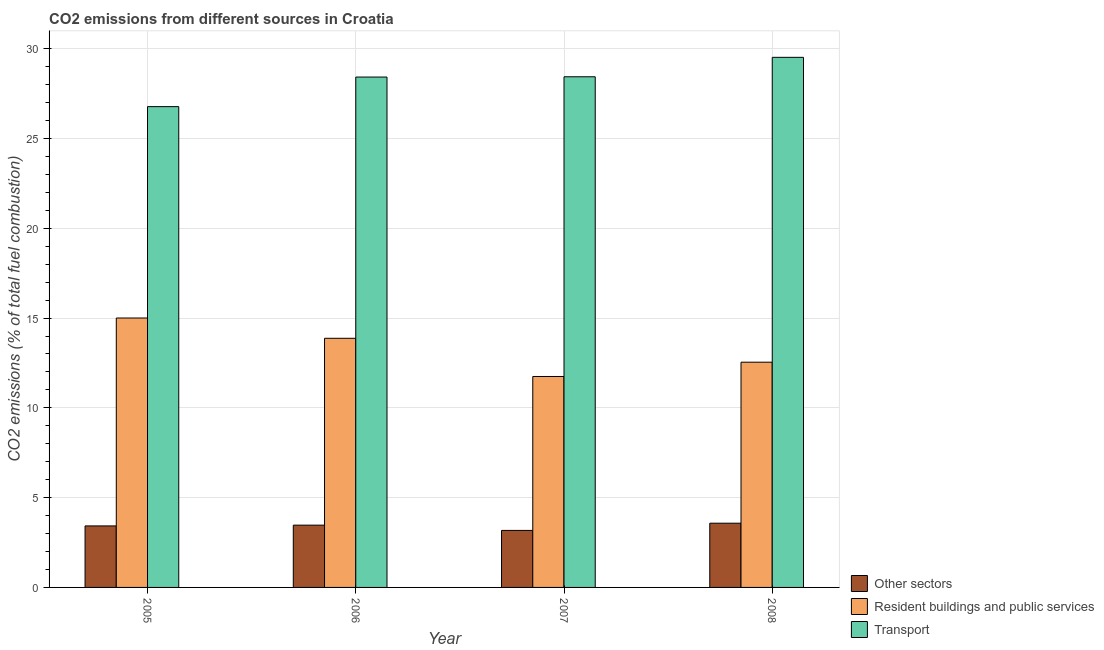How many different coloured bars are there?
Your response must be concise. 3. Are the number of bars per tick equal to the number of legend labels?
Provide a succinct answer. Yes. How many bars are there on the 2nd tick from the left?
Offer a very short reply. 3. How many bars are there on the 1st tick from the right?
Give a very brief answer. 3. In how many cases, is the number of bars for a given year not equal to the number of legend labels?
Offer a terse response. 0. What is the percentage of co2 emissions from transport in 2007?
Offer a terse response. 28.44. Across all years, what is the maximum percentage of co2 emissions from resident buildings and public services?
Keep it short and to the point. 15. Across all years, what is the minimum percentage of co2 emissions from other sectors?
Keep it short and to the point. 3.17. What is the total percentage of co2 emissions from transport in the graph?
Keep it short and to the point. 113.15. What is the difference between the percentage of co2 emissions from resident buildings and public services in 2005 and that in 2006?
Your answer should be very brief. 1.13. What is the difference between the percentage of co2 emissions from other sectors in 2007 and the percentage of co2 emissions from transport in 2005?
Ensure brevity in your answer.  -0.25. What is the average percentage of co2 emissions from resident buildings and public services per year?
Offer a very short reply. 13.29. In how many years, is the percentage of co2 emissions from transport greater than 11 %?
Make the answer very short. 4. What is the ratio of the percentage of co2 emissions from transport in 2007 to that in 2008?
Ensure brevity in your answer.  0.96. Is the percentage of co2 emissions from other sectors in 2006 less than that in 2007?
Offer a very short reply. No. Is the difference between the percentage of co2 emissions from transport in 2005 and 2006 greater than the difference between the percentage of co2 emissions from resident buildings and public services in 2005 and 2006?
Make the answer very short. No. What is the difference between the highest and the second highest percentage of co2 emissions from transport?
Make the answer very short. 1.08. What is the difference between the highest and the lowest percentage of co2 emissions from transport?
Ensure brevity in your answer.  2.75. In how many years, is the percentage of co2 emissions from transport greater than the average percentage of co2 emissions from transport taken over all years?
Give a very brief answer. 3. What does the 3rd bar from the left in 2007 represents?
Give a very brief answer. Transport. What does the 1st bar from the right in 2006 represents?
Make the answer very short. Transport. Are all the bars in the graph horizontal?
Provide a short and direct response. No. Where does the legend appear in the graph?
Keep it short and to the point. Bottom right. What is the title of the graph?
Offer a terse response. CO2 emissions from different sources in Croatia. What is the label or title of the Y-axis?
Your answer should be very brief. CO2 emissions (% of total fuel combustion). What is the CO2 emissions (% of total fuel combustion) of Other sectors in 2005?
Ensure brevity in your answer.  3.42. What is the CO2 emissions (% of total fuel combustion) in Resident buildings and public services in 2005?
Provide a succinct answer. 15. What is the CO2 emissions (% of total fuel combustion) of Transport in 2005?
Provide a short and direct response. 26.77. What is the CO2 emissions (% of total fuel combustion) of Other sectors in 2006?
Keep it short and to the point. 3.47. What is the CO2 emissions (% of total fuel combustion) in Resident buildings and public services in 2006?
Offer a very short reply. 13.87. What is the CO2 emissions (% of total fuel combustion) in Transport in 2006?
Keep it short and to the point. 28.42. What is the CO2 emissions (% of total fuel combustion) in Other sectors in 2007?
Offer a very short reply. 3.17. What is the CO2 emissions (% of total fuel combustion) of Resident buildings and public services in 2007?
Your answer should be very brief. 11.75. What is the CO2 emissions (% of total fuel combustion) in Transport in 2007?
Make the answer very short. 28.44. What is the CO2 emissions (% of total fuel combustion) of Other sectors in 2008?
Give a very brief answer. 3.58. What is the CO2 emissions (% of total fuel combustion) in Resident buildings and public services in 2008?
Give a very brief answer. 12.54. What is the CO2 emissions (% of total fuel combustion) of Transport in 2008?
Your response must be concise. 29.52. Across all years, what is the maximum CO2 emissions (% of total fuel combustion) in Other sectors?
Offer a terse response. 3.58. Across all years, what is the maximum CO2 emissions (% of total fuel combustion) in Resident buildings and public services?
Provide a succinct answer. 15. Across all years, what is the maximum CO2 emissions (% of total fuel combustion) in Transport?
Offer a terse response. 29.52. Across all years, what is the minimum CO2 emissions (% of total fuel combustion) of Other sectors?
Provide a short and direct response. 3.17. Across all years, what is the minimum CO2 emissions (% of total fuel combustion) in Resident buildings and public services?
Your answer should be very brief. 11.75. Across all years, what is the minimum CO2 emissions (% of total fuel combustion) in Transport?
Offer a very short reply. 26.77. What is the total CO2 emissions (% of total fuel combustion) in Other sectors in the graph?
Offer a terse response. 13.64. What is the total CO2 emissions (% of total fuel combustion) in Resident buildings and public services in the graph?
Your answer should be compact. 53.16. What is the total CO2 emissions (% of total fuel combustion) of Transport in the graph?
Your answer should be very brief. 113.15. What is the difference between the CO2 emissions (% of total fuel combustion) of Other sectors in 2005 and that in 2006?
Offer a terse response. -0.04. What is the difference between the CO2 emissions (% of total fuel combustion) of Resident buildings and public services in 2005 and that in 2006?
Make the answer very short. 1.13. What is the difference between the CO2 emissions (% of total fuel combustion) of Transport in 2005 and that in 2006?
Your response must be concise. -1.65. What is the difference between the CO2 emissions (% of total fuel combustion) in Other sectors in 2005 and that in 2007?
Offer a very short reply. 0.25. What is the difference between the CO2 emissions (% of total fuel combustion) of Resident buildings and public services in 2005 and that in 2007?
Ensure brevity in your answer.  3.26. What is the difference between the CO2 emissions (% of total fuel combustion) of Transport in 2005 and that in 2007?
Your answer should be very brief. -1.66. What is the difference between the CO2 emissions (% of total fuel combustion) of Other sectors in 2005 and that in 2008?
Provide a succinct answer. -0.15. What is the difference between the CO2 emissions (% of total fuel combustion) of Resident buildings and public services in 2005 and that in 2008?
Offer a terse response. 2.46. What is the difference between the CO2 emissions (% of total fuel combustion) in Transport in 2005 and that in 2008?
Ensure brevity in your answer.  -2.75. What is the difference between the CO2 emissions (% of total fuel combustion) of Other sectors in 2006 and that in 2007?
Give a very brief answer. 0.29. What is the difference between the CO2 emissions (% of total fuel combustion) in Resident buildings and public services in 2006 and that in 2007?
Your response must be concise. 2.13. What is the difference between the CO2 emissions (% of total fuel combustion) of Transport in 2006 and that in 2007?
Provide a short and direct response. -0.02. What is the difference between the CO2 emissions (% of total fuel combustion) in Other sectors in 2006 and that in 2008?
Provide a short and direct response. -0.11. What is the difference between the CO2 emissions (% of total fuel combustion) in Resident buildings and public services in 2006 and that in 2008?
Offer a very short reply. 1.33. What is the difference between the CO2 emissions (% of total fuel combustion) of Transport in 2006 and that in 2008?
Your answer should be very brief. -1.1. What is the difference between the CO2 emissions (% of total fuel combustion) of Other sectors in 2007 and that in 2008?
Offer a terse response. -0.4. What is the difference between the CO2 emissions (% of total fuel combustion) in Resident buildings and public services in 2007 and that in 2008?
Provide a short and direct response. -0.8. What is the difference between the CO2 emissions (% of total fuel combustion) in Transport in 2007 and that in 2008?
Your answer should be very brief. -1.08. What is the difference between the CO2 emissions (% of total fuel combustion) of Other sectors in 2005 and the CO2 emissions (% of total fuel combustion) of Resident buildings and public services in 2006?
Offer a very short reply. -10.45. What is the difference between the CO2 emissions (% of total fuel combustion) of Other sectors in 2005 and the CO2 emissions (% of total fuel combustion) of Transport in 2006?
Ensure brevity in your answer.  -25. What is the difference between the CO2 emissions (% of total fuel combustion) of Resident buildings and public services in 2005 and the CO2 emissions (% of total fuel combustion) of Transport in 2006?
Your answer should be very brief. -13.42. What is the difference between the CO2 emissions (% of total fuel combustion) of Other sectors in 2005 and the CO2 emissions (% of total fuel combustion) of Resident buildings and public services in 2007?
Your answer should be compact. -8.32. What is the difference between the CO2 emissions (% of total fuel combustion) of Other sectors in 2005 and the CO2 emissions (% of total fuel combustion) of Transport in 2007?
Provide a short and direct response. -25.01. What is the difference between the CO2 emissions (% of total fuel combustion) in Resident buildings and public services in 2005 and the CO2 emissions (% of total fuel combustion) in Transport in 2007?
Your answer should be very brief. -13.43. What is the difference between the CO2 emissions (% of total fuel combustion) in Other sectors in 2005 and the CO2 emissions (% of total fuel combustion) in Resident buildings and public services in 2008?
Offer a terse response. -9.12. What is the difference between the CO2 emissions (% of total fuel combustion) of Other sectors in 2005 and the CO2 emissions (% of total fuel combustion) of Transport in 2008?
Provide a succinct answer. -26.09. What is the difference between the CO2 emissions (% of total fuel combustion) in Resident buildings and public services in 2005 and the CO2 emissions (% of total fuel combustion) in Transport in 2008?
Your answer should be compact. -14.52. What is the difference between the CO2 emissions (% of total fuel combustion) of Other sectors in 2006 and the CO2 emissions (% of total fuel combustion) of Resident buildings and public services in 2007?
Your response must be concise. -8.28. What is the difference between the CO2 emissions (% of total fuel combustion) in Other sectors in 2006 and the CO2 emissions (% of total fuel combustion) in Transport in 2007?
Keep it short and to the point. -24.97. What is the difference between the CO2 emissions (% of total fuel combustion) in Resident buildings and public services in 2006 and the CO2 emissions (% of total fuel combustion) in Transport in 2007?
Keep it short and to the point. -14.56. What is the difference between the CO2 emissions (% of total fuel combustion) of Other sectors in 2006 and the CO2 emissions (% of total fuel combustion) of Resident buildings and public services in 2008?
Keep it short and to the point. -9.07. What is the difference between the CO2 emissions (% of total fuel combustion) in Other sectors in 2006 and the CO2 emissions (% of total fuel combustion) in Transport in 2008?
Provide a short and direct response. -26.05. What is the difference between the CO2 emissions (% of total fuel combustion) in Resident buildings and public services in 2006 and the CO2 emissions (% of total fuel combustion) in Transport in 2008?
Offer a very short reply. -15.65. What is the difference between the CO2 emissions (% of total fuel combustion) in Other sectors in 2007 and the CO2 emissions (% of total fuel combustion) in Resident buildings and public services in 2008?
Give a very brief answer. -9.37. What is the difference between the CO2 emissions (% of total fuel combustion) in Other sectors in 2007 and the CO2 emissions (% of total fuel combustion) in Transport in 2008?
Offer a very short reply. -26.34. What is the difference between the CO2 emissions (% of total fuel combustion) in Resident buildings and public services in 2007 and the CO2 emissions (% of total fuel combustion) in Transport in 2008?
Provide a short and direct response. -17.77. What is the average CO2 emissions (% of total fuel combustion) in Other sectors per year?
Your answer should be very brief. 3.41. What is the average CO2 emissions (% of total fuel combustion) in Resident buildings and public services per year?
Your answer should be very brief. 13.29. What is the average CO2 emissions (% of total fuel combustion) of Transport per year?
Give a very brief answer. 28.29. In the year 2005, what is the difference between the CO2 emissions (% of total fuel combustion) in Other sectors and CO2 emissions (% of total fuel combustion) in Resident buildings and public services?
Offer a terse response. -11.58. In the year 2005, what is the difference between the CO2 emissions (% of total fuel combustion) of Other sectors and CO2 emissions (% of total fuel combustion) of Transport?
Your answer should be very brief. -23.35. In the year 2005, what is the difference between the CO2 emissions (% of total fuel combustion) of Resident buildings and public services and CO2 emissions (% of total fuel combustion) of Transport?
Your response must be concise. -11.77. In the year 2006, what is the difference between the CO2 emissions (% of total fuel combustion) in Other sectors and CO2 emissions (% of total fuel combustion) in Resident buildings and public services?
Your answer should be compact. -10.4. In the year 2006, what is the difference between the CO2 emissions (% of total fuel combustion) in Other sectors and CO2 emissions (% of total fuel combustion) in Transport?
Your answer should be very brief. -24.95. In the year 2006, what is the difference between the CO2 emissions (% of total fuel combustion) of Resident buildings and public services and CO2 emissions (% of total fuel combustion) of Transport?
Give a very brief answer. -14.55. In the year 2007, what is the difference between the CO2 emissions (% of total fuel combustion) of Other sectors and CO2 emissions (% of total fuel combustion) of Resident buildings and public services?
Make the answer very short. -8.57. In the year 2007, what is the difference between the CO2 emissions (% of total fuel combustion) of Other sectors and CO2 emissions (% of total fuel combustion) of Transport?
Your answer should be compact. -25.26. In the year 2007, what is the difference between the CO2 emissions (% of total fuel combustion) in Resident buildings and public services and CO2 emissions (% of total fuel combustion) in Transport?
Ensure brevity in your answer.  -16.69. In the year 2008, what is the difference between the CO2 emissions (% of total fuel combustion) in Other sectors and CO2 emissions (% of total fuel combustion) in Resident buildings and public services?
Provide a short and direct response. -8.97. In the year 2008, what is the difference between the CO2 emissions (% of total fuel combustion) in Other sectors and CO2 emissions (% of total fuel combustion) in Transport?
Offer a very short reply. -25.94. In the year 2008, what is the difference between the CO2 emissions (% of total fuel combustion) in Resident buildings and public services and CO2 emissions (% of total fuel combustion) in Transport?
Give a very brief answer. -16.98. What is the ratio of the CO2 emissions (% of total fuel combustion) of Other sectors in 2005 to that in 2006?
Ensure brevity in your answer.  0.99. What is the ratio of the CO2 emissions (% of total fuel combustion) in Resident buildings and public services in 2005 to that in 2006?
Keep it short and to the point. 1.08. What is the ratio of the CO2 emissions (% of total fuel combustion) of Transport in 2005 to that in 2006?
Provide a short and direct response. 0.94. What is the ratio of the CO2 emissions (% of total fuel combustion) of Other sectors in 2005 to that in 2007?
Keep it short and to the point. 1.08. What is the ratio of the CO2 emissions (% of total fuel combustion) of Resident buildings and public services in 2005 to that in 2007?
Give a very brief answer. 1.28. What is the ratio of the CO2 emissions (% of total fuel combustion) of Transport in 2005 to that in 2007?
Provide a succinct answer. 0.94. What is the ratio of the CO2 emissions (% of total fuel combustion) in Other sectors in 2005 to that in 2008?
Offer a very short reply. 0.96. What is the ratio of the CO2 emissions (% of total fuel combustion) in Resident buildings and public services in 2005 to that in 2008?
Give a very brief answer. 1.2. What is the ratio of the CO2 emissions (% of total fuel combustion) of Transport in 2005 to that in 2008?
Give a very brief answer. 0.91. What is the ratio of the CO2 emissions (% of total fuel combustion) of Other sectors in 2006 to that in 2007?
Make the answer very short. 1.09. What is the ratio of the CO2 emissions (% of total fuel combustion) of Resident buildings and public services in 2006 to that in 2007?
Your response must be concise. 1.18. What is the ratio of the CO2 emissions (% of total fuel combustion) of Other sectors in 2006 to that in 2008?
Provide a short and direct response. 0.97. What is the ratio of the CO2 emissions (% of total fuel combustion) of Resident buildings and public services in 2006 to that in 2008?
Ensure brevity in your answer.  1.11. What is the ratio of the CO2 emissions (% of total fuel combustion) of Transport in 2006 to that in 2008?
Keep it short and to the point. 0.96. What is the ratio of the CO2 emissions (% of total fuel combustion) of Other sectors in 2007 to that in 2008?
Provide a short and direct response. 0.89. What is the ratio of the CO2 emissions (% of total fuel combustion) of Resident buildings and public services in 2007 to that in 2008?
Ensure brevity in your answer.  0.94. What is the ratio of the CO2 emissions (% of total fuel combustion) of Transport in 2007 to that in 2008?
Your answer should be very brief. 0.96. What is the difference between the highest and the second highest CO2 emissions (% of total fuel combustion) in Other sectors?
Give a very brief answer. 0.11. What is the difference between the highest and the second highest CO2 emissions (% of total fuel combustion) in Resident buildings and public services?
Ensure brevity in your answer.  1.13. What is the difference between the highest and the second highest CO2 emissions (% of total fuel combustion) in Transport?
Give a very brief answer. 1.08. What is the difference between the highest and the lowest CO2 emissions (% of total fuel combustion) of Other sectors?
Offer a terse response. 0.4. What is the difference between the highest and the lowest CO2 emissions (% of total fuel combustion) of Resident buildings and public services?
Your response must be concise. 3.26. What is the difference between the highest and the lowest CO2 emissions (% of total fuel combustion) of Transport?
Ensure brevity in your answer.  2.75. 